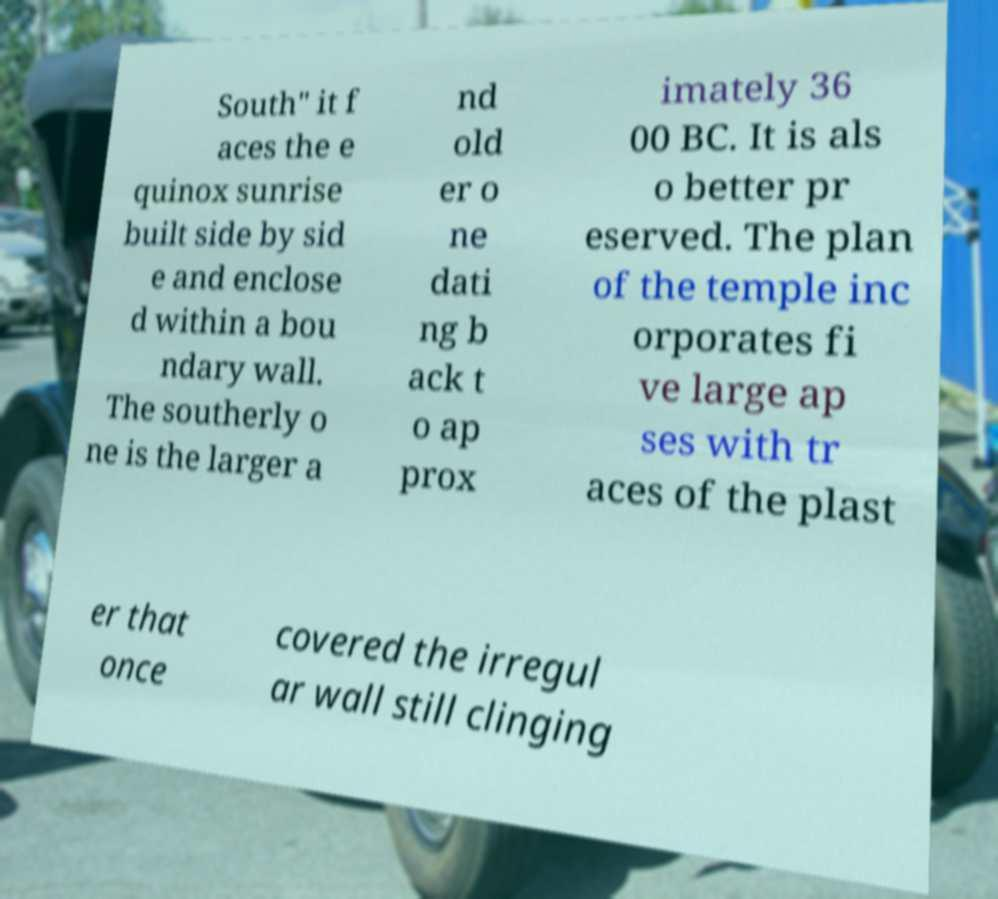I need the written content from this picture converted into text. Can you do that? South" it f aces the e quinox sunrise built side by sid e and enclose d within a bou ndary wall. The southerly o ne is the larger a nd old er o ne dati ng b ack t o ap prox imately 36 00 BC. It is als o better pr eserved. The plan of the temple inc orporates fi ve large ap ses with tr aces of the plast er that once covered the irregul ar wall still clinging 